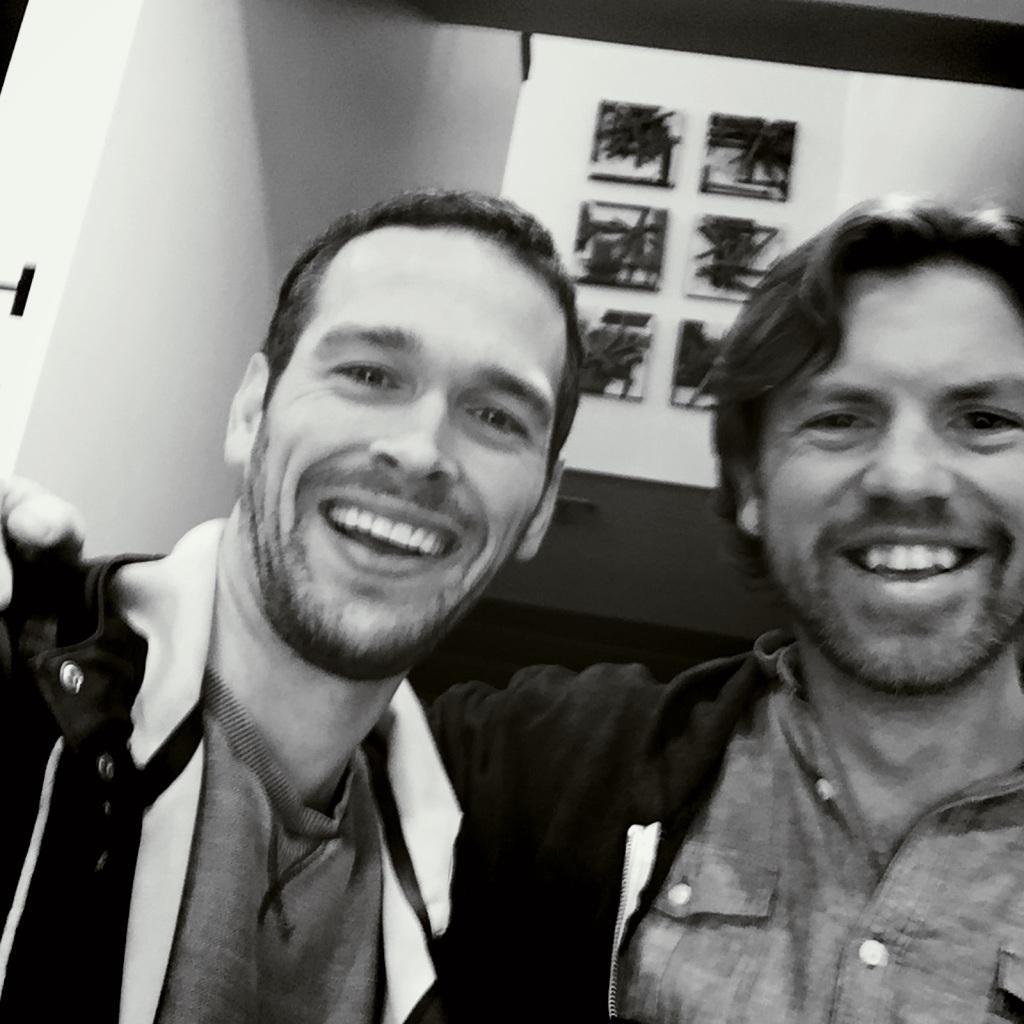Describe this image in one or two sentences. This is a black and white image. In the center of the image we can see two persons are standing and smiling. In the background of the image we can see the wall and photo frames. At the top of the image we can see the roof. 